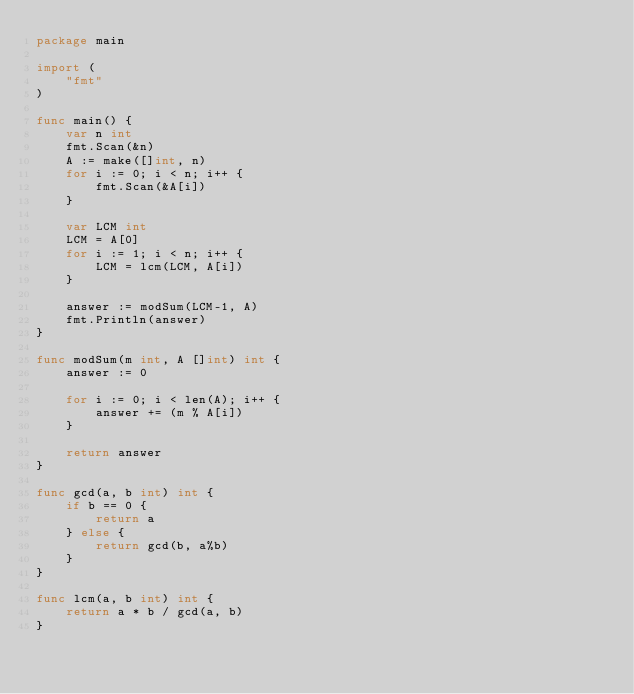<code> <loc_0><loc_0><loc_500><loc_500><_Go_>package main

import (
	"fmt"
)

func main() {
	var n int
	fmt.Scan(&n)
	A := make([]int, n)
	for i := 0; i < n; i++ {
		fmt.Scan(&A[i])
	}

	var LCM int
	LCM = A[0]
	for i := 1; i < n; i++ {
		LCM = lcm(LCM, A[i])
	}

	answer := modSum(LCM-1, A)
	fmt.Println(answer)
}

func modSum(m int, A []int) int {
	answer := 0

	for i := 0; i < len(A); i++ {
		answer += (m % A[i])
	}

	return answer
}

func gcd(a, b int) int {
	if b == 0 {
		return a
	} else {
		return gcd(b, a%b)
	}
}

func lcm(a, b int) int {
	return a * b / gcd(a, b)
}
</code> 